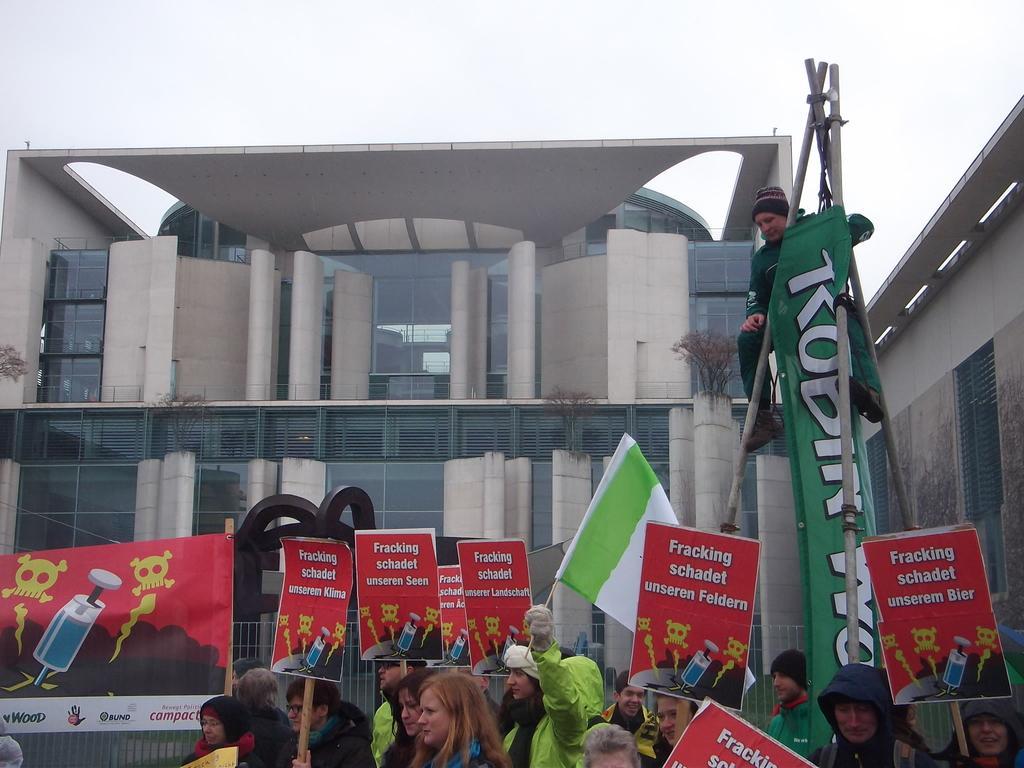Can you describe this image briefly? In this picture we can see a group of people, posters, banners, flag, poles, sculpture, fence, buildings, plants and in the background we can see the sky. 